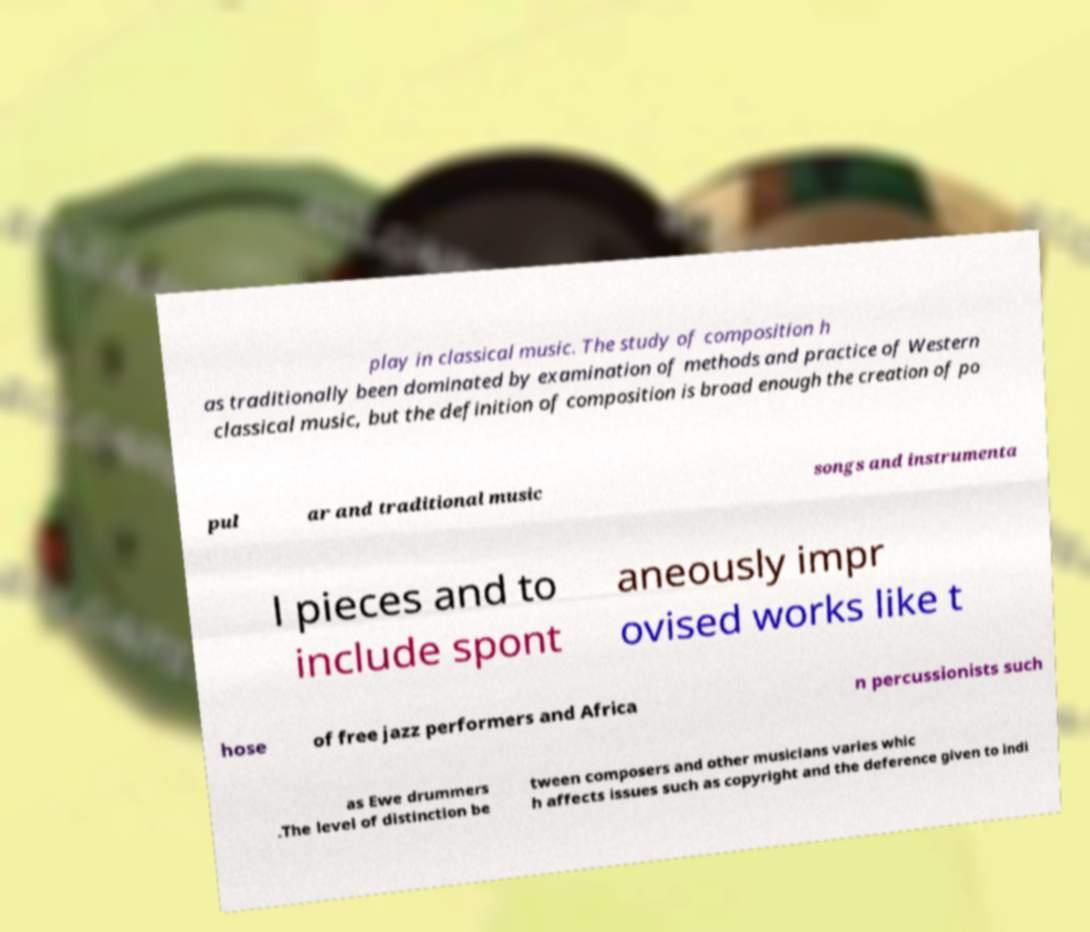Please read and relay the text visible in this image. What does it say? play in classical music. The study of composition h as traditionally been dominated by examination of methods and practice of Western classical music, but the definition of composition is broad enough the creation of po pul ar and traditional music songs and instrumenta l pieces and to include spont aneously impr ovised works like t hose of free jazz performers and Africa n percussionists such as Ewe drummers .The level of distinction be tween composers and other musicians varies whic h affects issues such as copyright and the deference given to indi 